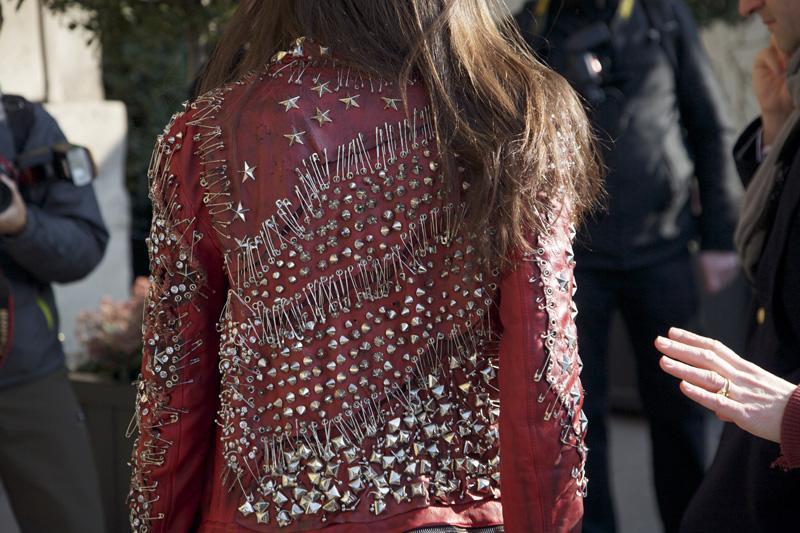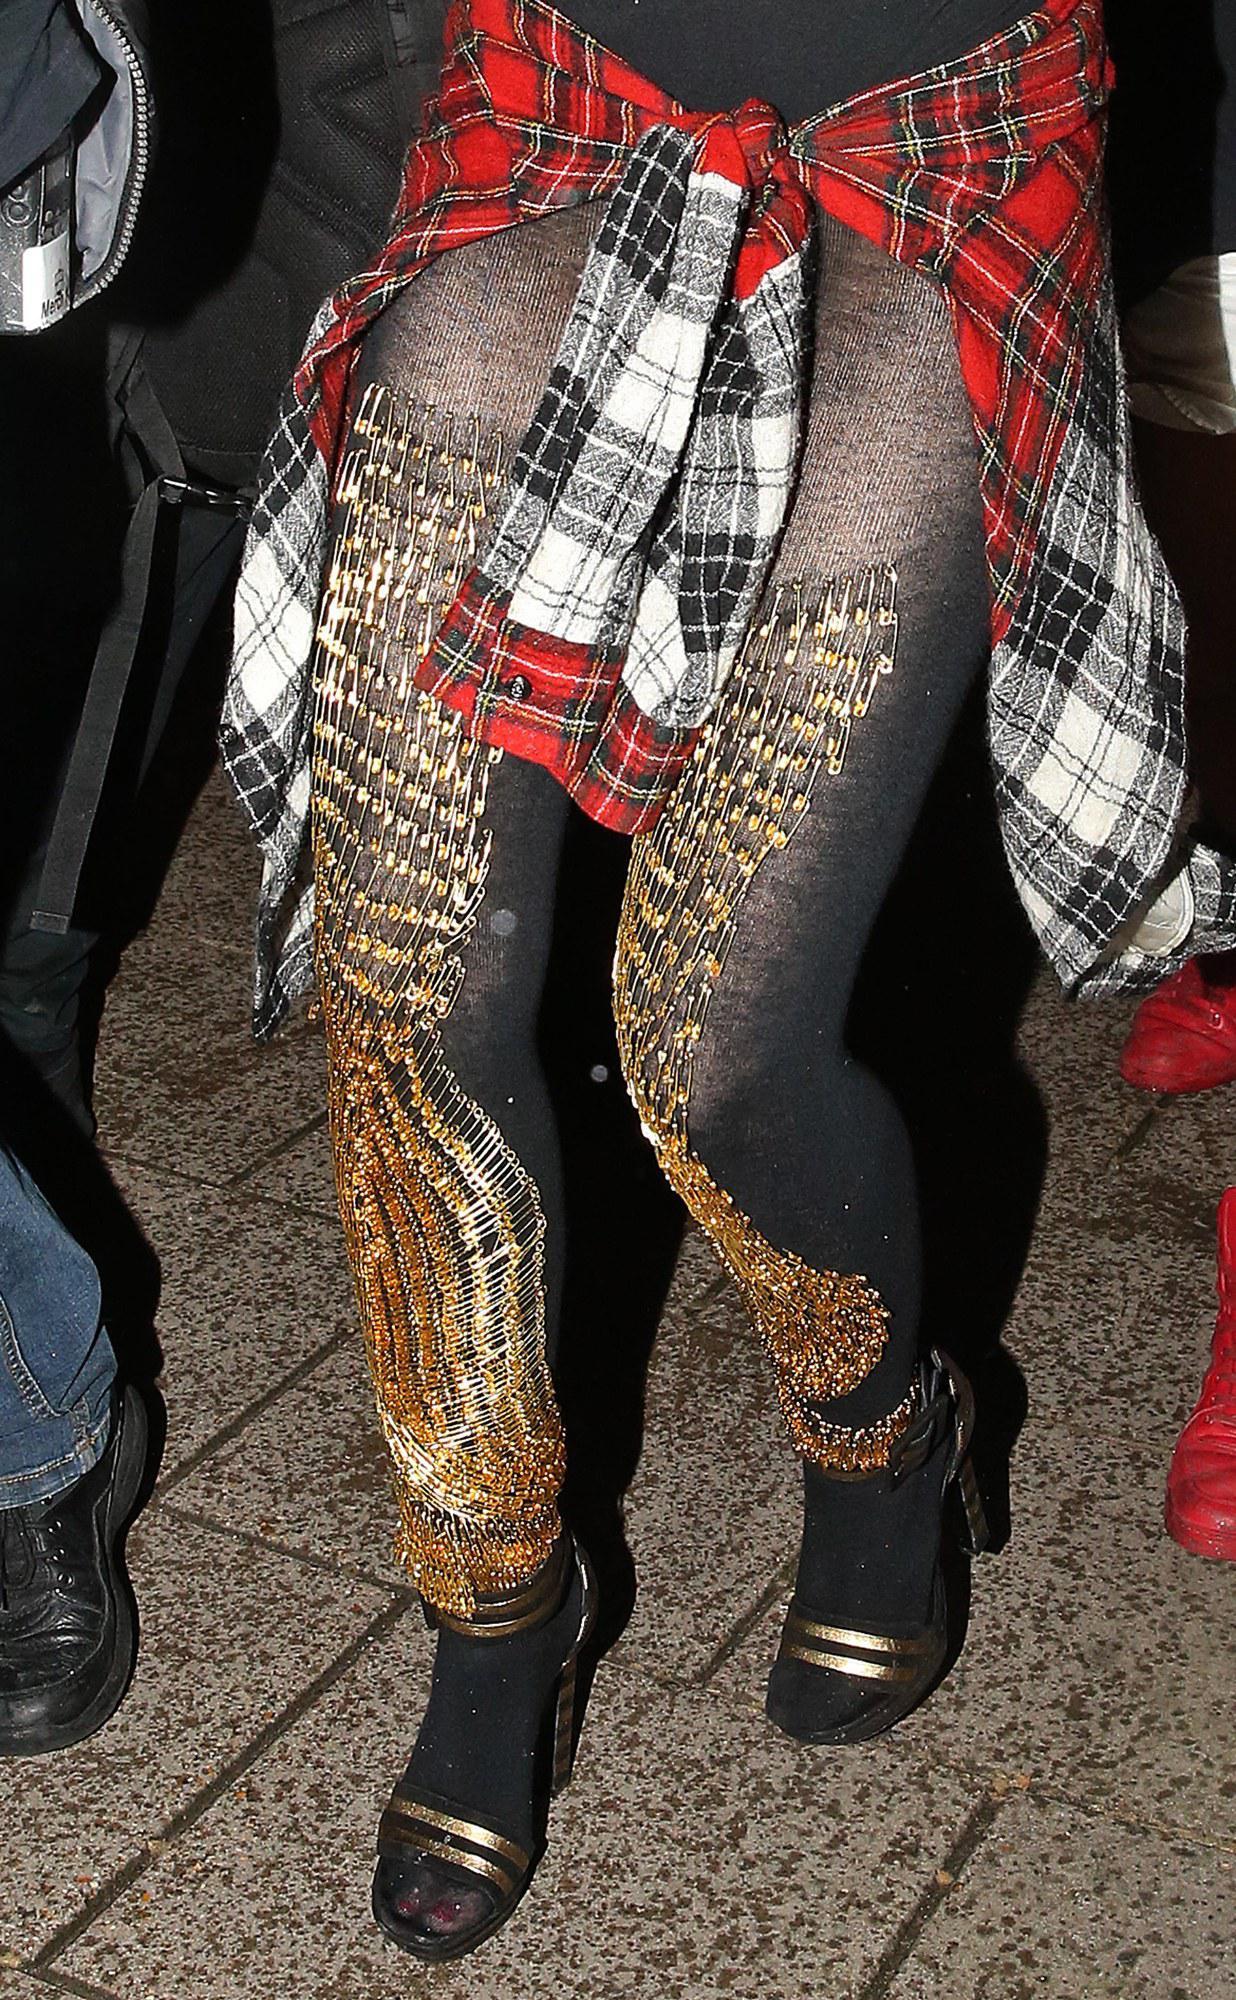The first image is the image on the left, the second image is the image on the right. For the images shown, is this caption "You cannot see the face of at least one of the models." true? Answer yes or no. Yes. The first image is the image on the left, the second image is the image on the right. Considering the images on both sides, is "At least one front view and one back view of fashions are shown by models." valid? Answer yes or no. Yes. 